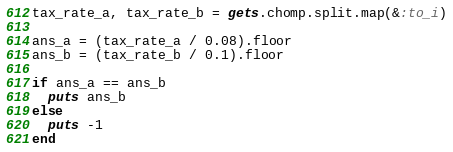Convert code to text. <code><loc_0><loc_0><loc_500><loc_500><_Ruby_>tax_rate_a, tax_rate_b = gets.chomp.split.map(&:to_i)

ans_a = (tax_rate_a / 0.08).floor
ans_b = (tax_rate_b / 0.1).floor

if ans_a == ans_b
  puts ans_b
else
  puts -1
end</code> 